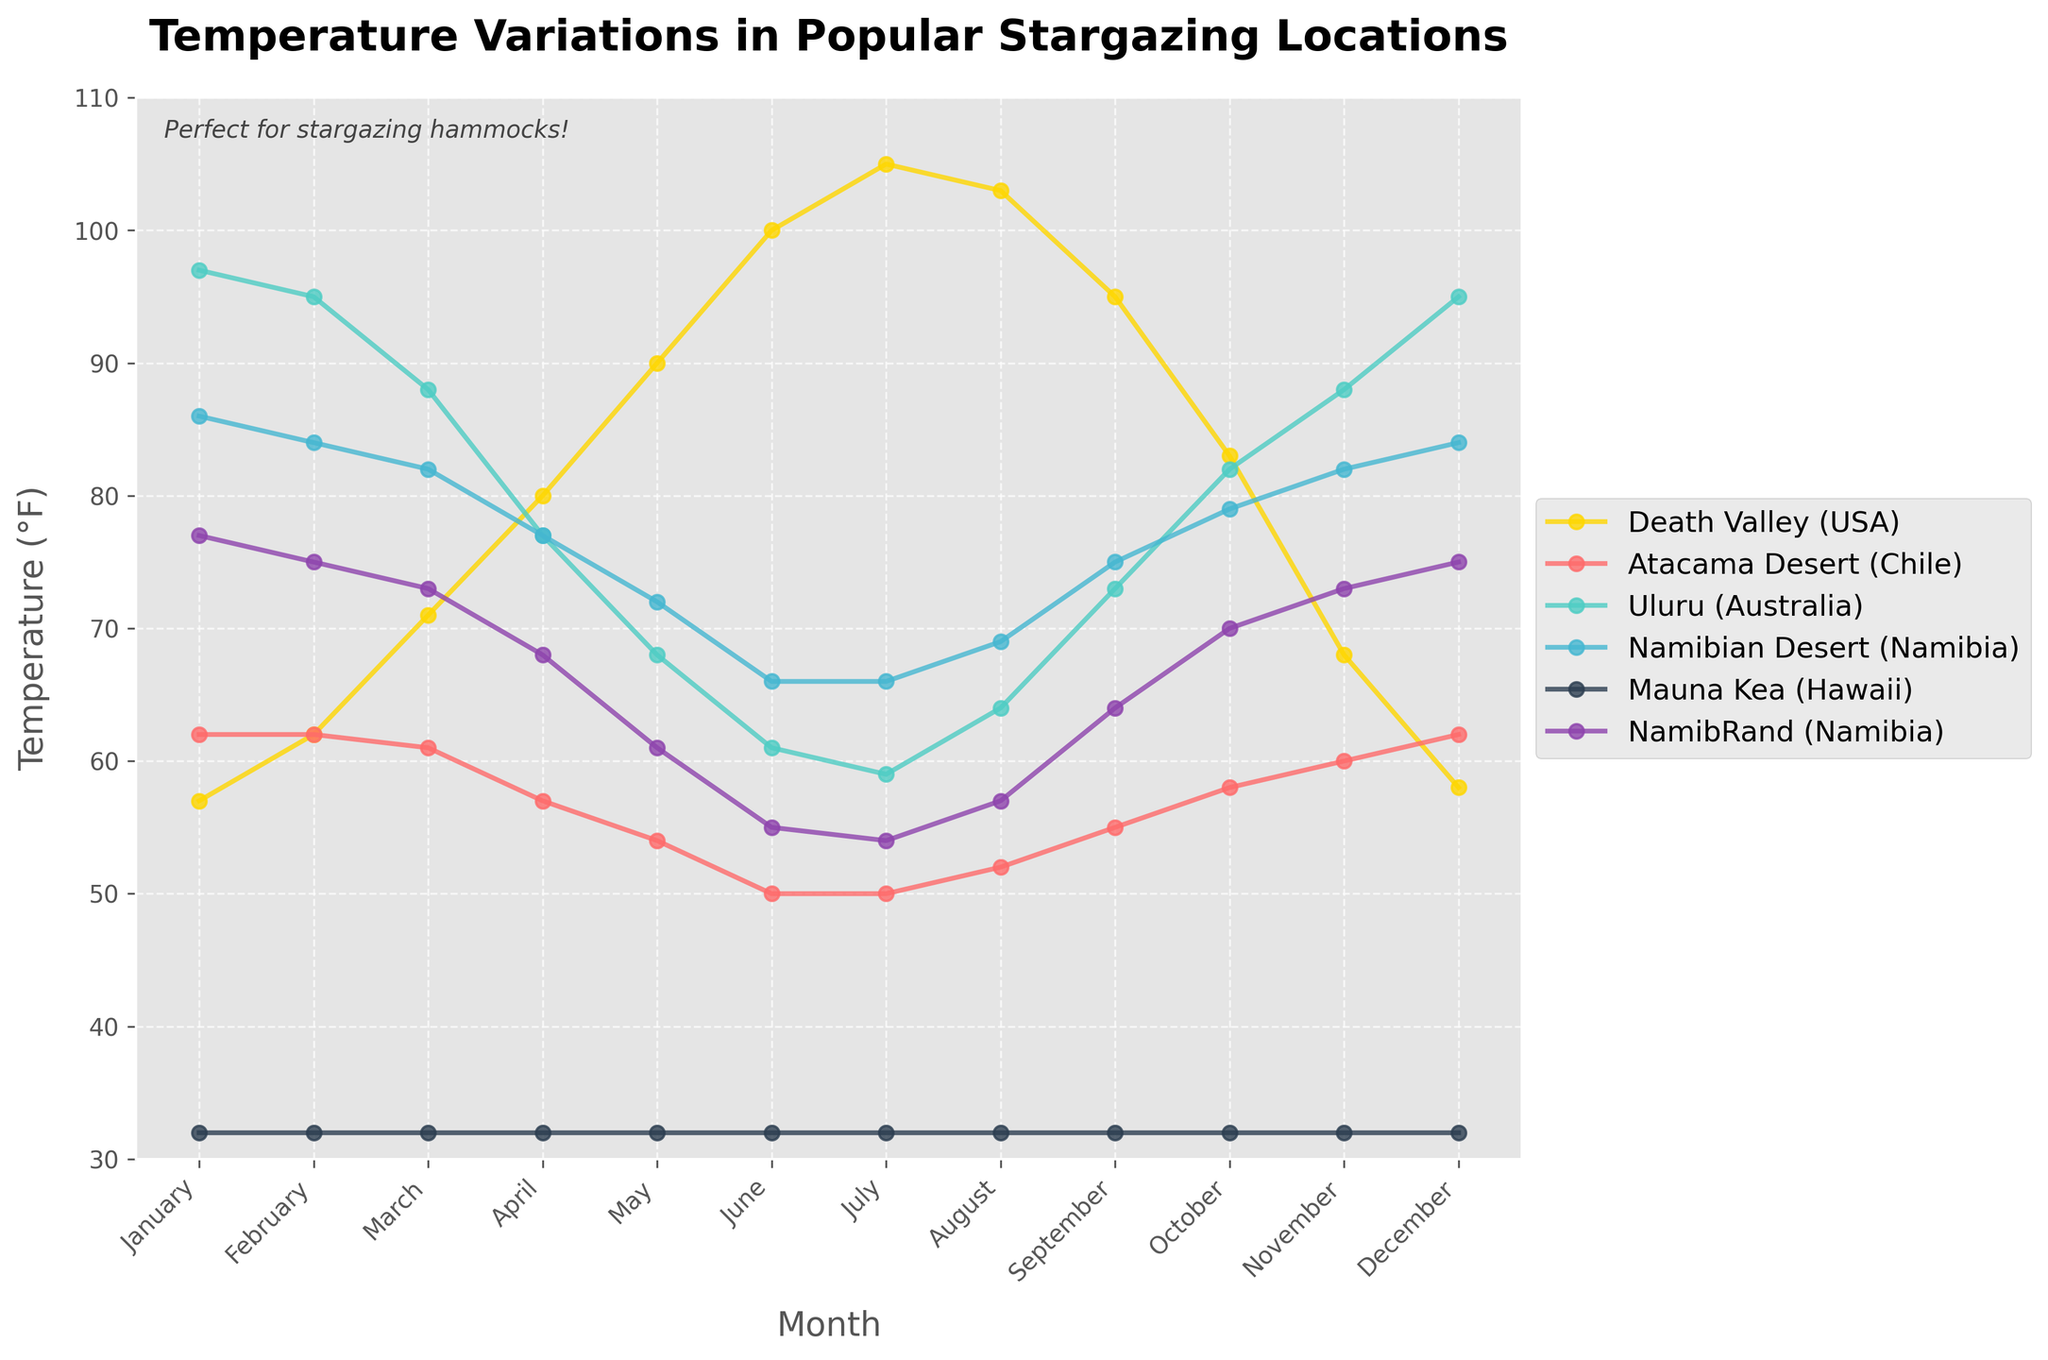What is the average temperature of Death Valley in the summer months (June, July, August)? The temperature in Death Valley for June, July, and August are 100°F, 105°F, and 103°F respectively. Adding these values gives 308°F, and dividing by 3, the average is \( \frac{308}{3} \) ≈ 102.67°F
Answer: 102.67°F Which location has the lowest average temperature in July? The temperatures in July are Death Valley (105°F), Atacama Desert (50°F), Uluru (59°F), Namibian Desert (66°F), Mauna Kea (32°F), NamibRand (54°F). The lowest temperature is 32°F at Mauna Kea
Answer: Mauna Kea How does the temperature in Mauna Kea in January compare to that in July? In January, the temperature in Mauna Kea is 32°F, and in July, it is also 32°F. Therefore, the temperatures are equal.
Answer: equal What is the temperature range (difference between the highest and lowest temperatures) in Uluru throughout the year? The highest temperature in Uluru is 97°F (January) and the lowest is 59°F (July). The range is 97°F - 59°F = 38°F
Answer: 38°F What location has the highest temperature in April? The April temperatures are: Death Valley (80°F), Atacama Desert (57°F), Uluru (77°F), Namibian Desert (77°F), Mauna Kea (32°F), NamibRand (68°F). Death Valley has the highest temperature at 80°F
Answer: Death Valley During which month does the Atacama Desert have its highest temperature, and what is the temperature? The highest temperature in the Atacama Desert occurs in January, February, and December, all at 62°F
Answer: January, February, and December; 62°F Describe the general trend of temperatures in the Namibian Desert from June to November. From June (66°F) to November (82°F), the temperature in the Namibian Desert generally increases: June (66°F), July (66°F), August (69°F), September (75°F), October (79°F), November (82°F)
Answer: Increasing Which location maintains the most consistent temperature throughout the year, and what is the approximate temperature? Mauna Kea shows the most consistent temperature throughout the year, maintaining near 32°F in all months
Answer: Mauna Kea, 32°F What is the average temperature in NamibRand for the months January, February, and December? The temperatures in NamibRand for January, February, and December are 77°F, 75°F, and 75°F respectively. Adding these values gives 227°F, and dividing by 3, the average is \( \frac{227}{3} \) ≈ 75.67°F
Answer: 75.67°F 